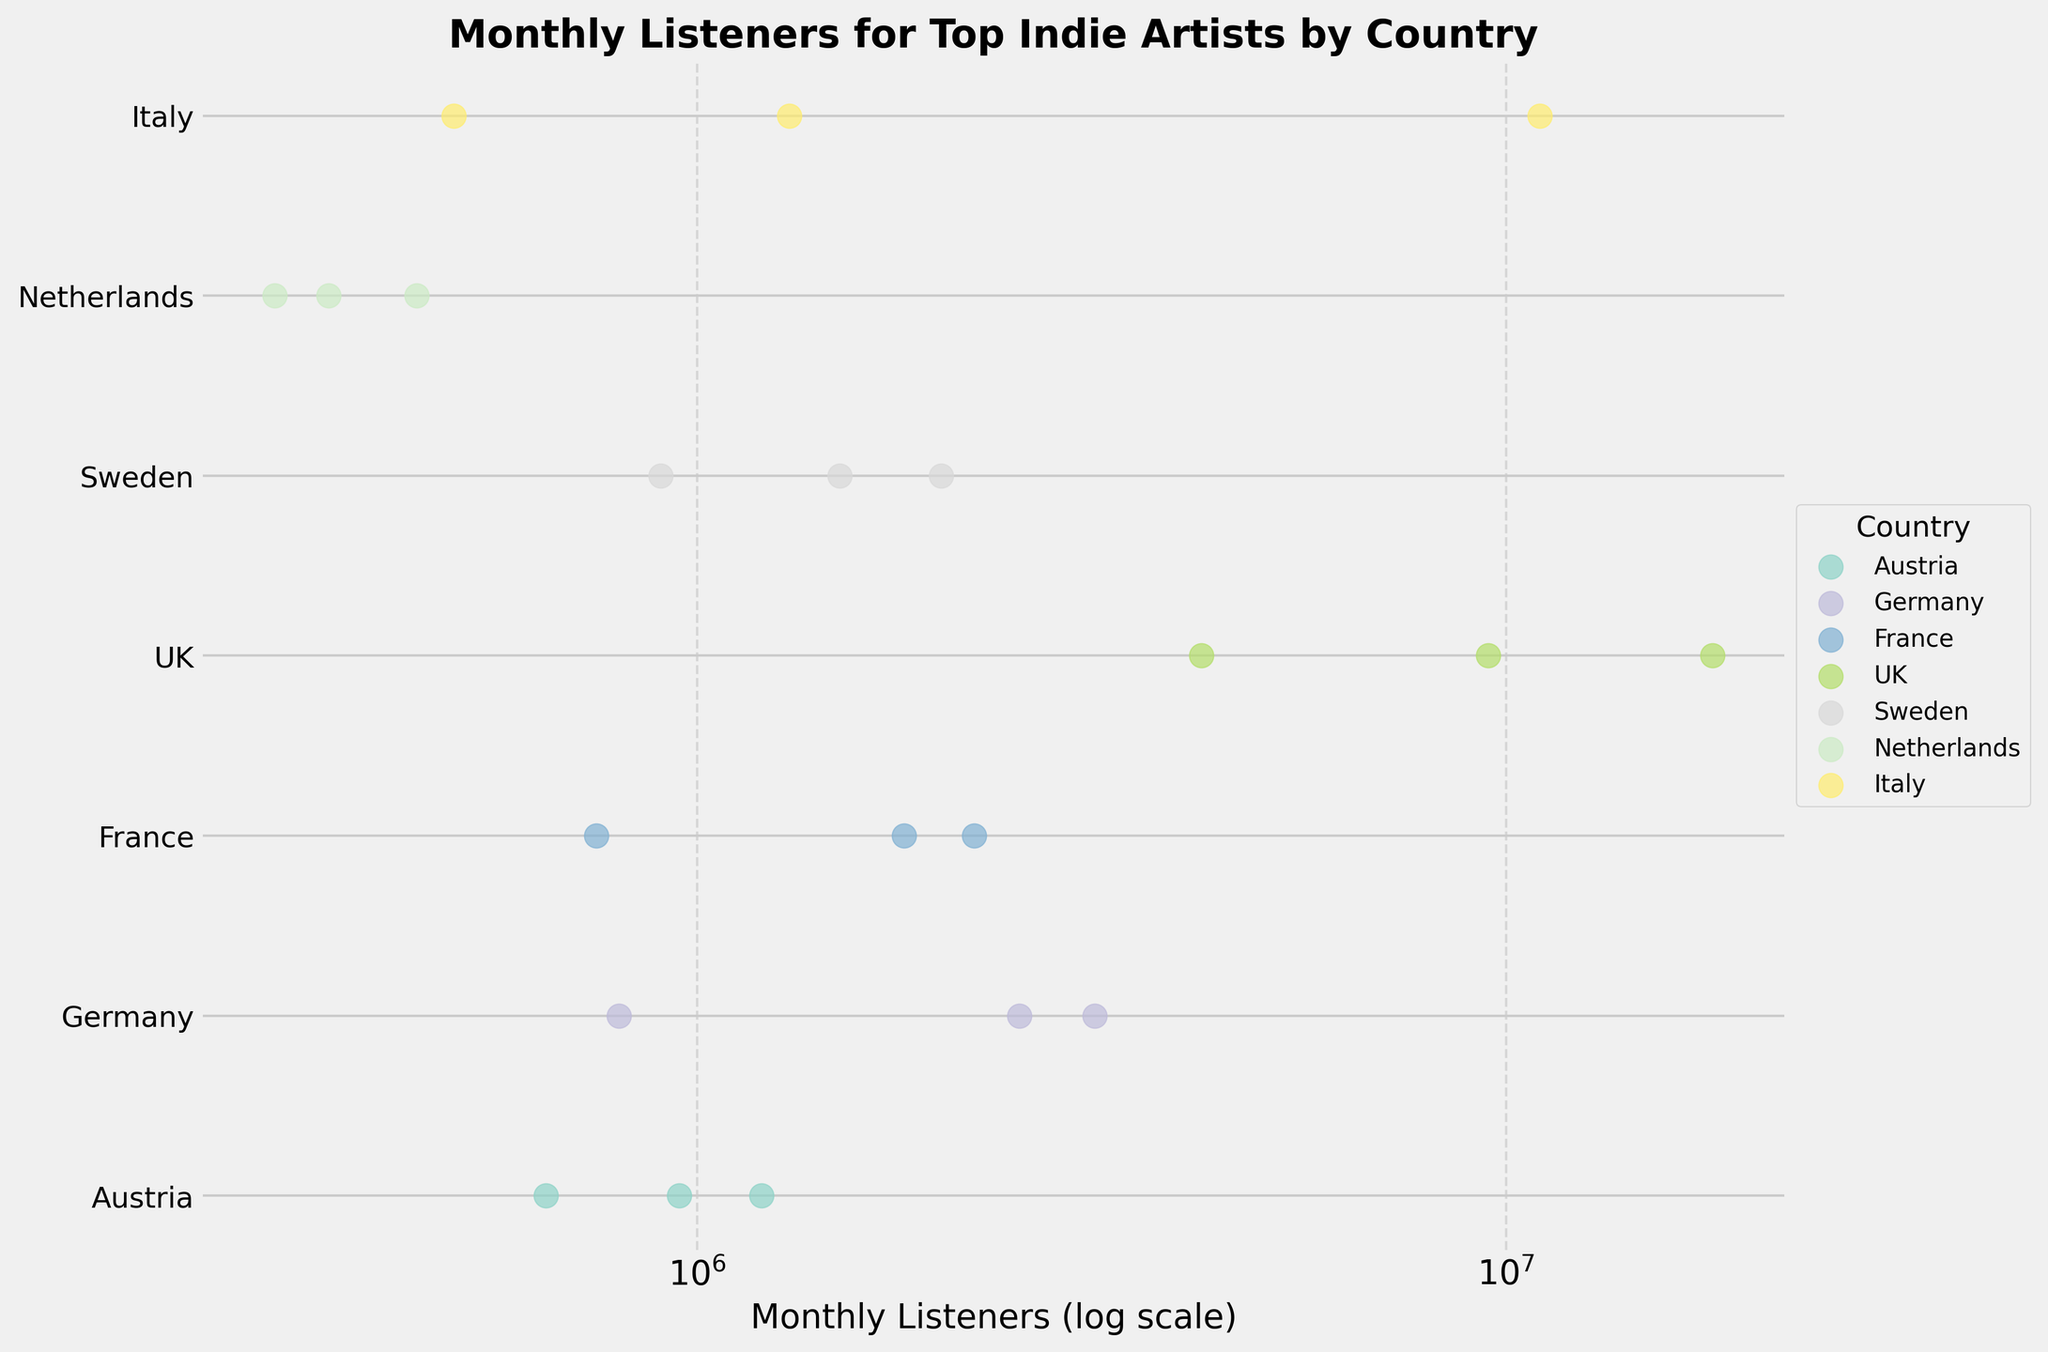What is the title of the plot? The title is usually located at the top of the plot and is the largest text; it reads: 'Monthly Listeners for Top Indie Artists by Country'.
Answer: Monthly Listeners for Top Indie Artists by Country Which country has the artist with the highest number of monthly listeners? The data points are color-coded, and the UK has the artist 'Arctic Monkeys' with 18,000,000 monthly listeners, the highest in the plot.
Answer: UK How many artists from Germany are shown in the plot? Identify the data points in the same color representing Germany and count them. There are three: 'AnnenMayKantereit', 'Milky Chance', and 'Von Wegen Lisbeth'.
Answer: 3 Which country has the artist with the fewest monthly listeners? Look for the smallest value on the x-axis and check the corresponding y-axis label. 'Eefje de Visser' from the Netherlands has the lowest at 300,000 monthly listeners.
Answer: Netherlands What is the average number of monthly listeners for the artists from France? Add the monthly listeners of all the French artists and divide by the number of artists: (1,800,000 + 2,200,000 + 750,000) / 3 = 1,583,333.33
Answer: 1,583,333.33 Which country has the largest spread in the number of monthly listeners among its artists? Compare the range (difference between the highest and lowest values) for each country. The UK has the largest range with 'Arctic Monkeys' at 18,000,000 and 'alt-J' at 4,200,000, resulting in a spread of 13,800,000.
Answer: UK Are there any countries where all the artists have more than 1,000,000 monthly listeners? Check each country to see if all their artists have values above 1,000,000 monthly listeners. Only the UK meets this criterion.
Answer: Yes, the UK Is there a country where the log-scaled monthly listeners don't vary much among its artists? Look for countries where the data points are closely packed together on the x-axis. Germany's artists cluster around the 1,000,000 to 3,000,000 range without extreme outliers.
Answer: Germany Which artists have monthly listeners between 1,000,000 and 2,000,000? Check the x-axis for values within this range and identify the corresponding data points: 'Christine and the Queens', 'Bilderbuch', 'Calcutta', and 'Lykke Li'.
Answer: Christine and the Queens, Bilderbuch, Calcutta, Lykke Li 